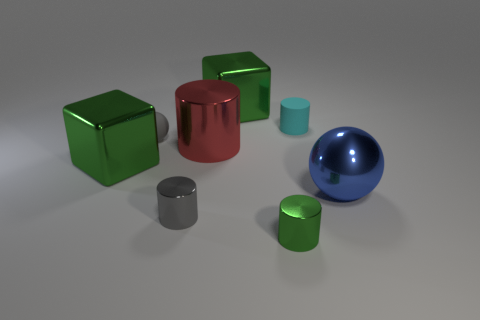Add 1 small green objects. How many objects exist? 9 Subtract all spheres. How many objects are left? 6 Subtract all red cylinders. Subtract all large red rubber balls. How many objects are left? 7 Add 1 small gray cylinders. How many small gray cylinders are left? 2 Add 1 red things. How many red things exist? 2 Subtract 0 brown spheres. How many objects are left? 8 